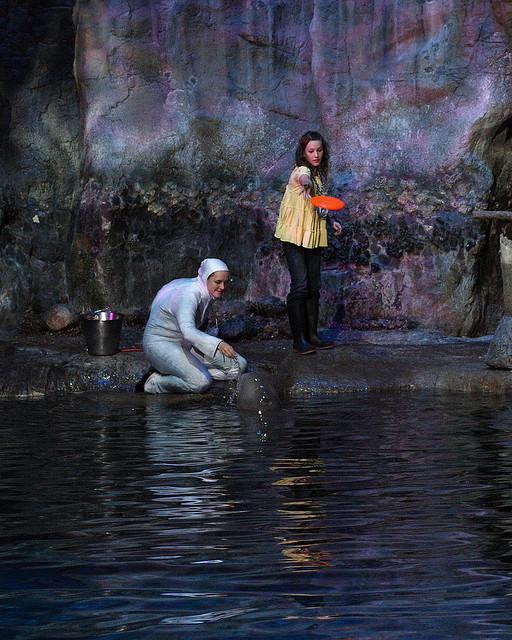How many people?
Give a very brief answer. 2. How many people are visible?
Give a very brief answer. 2. 